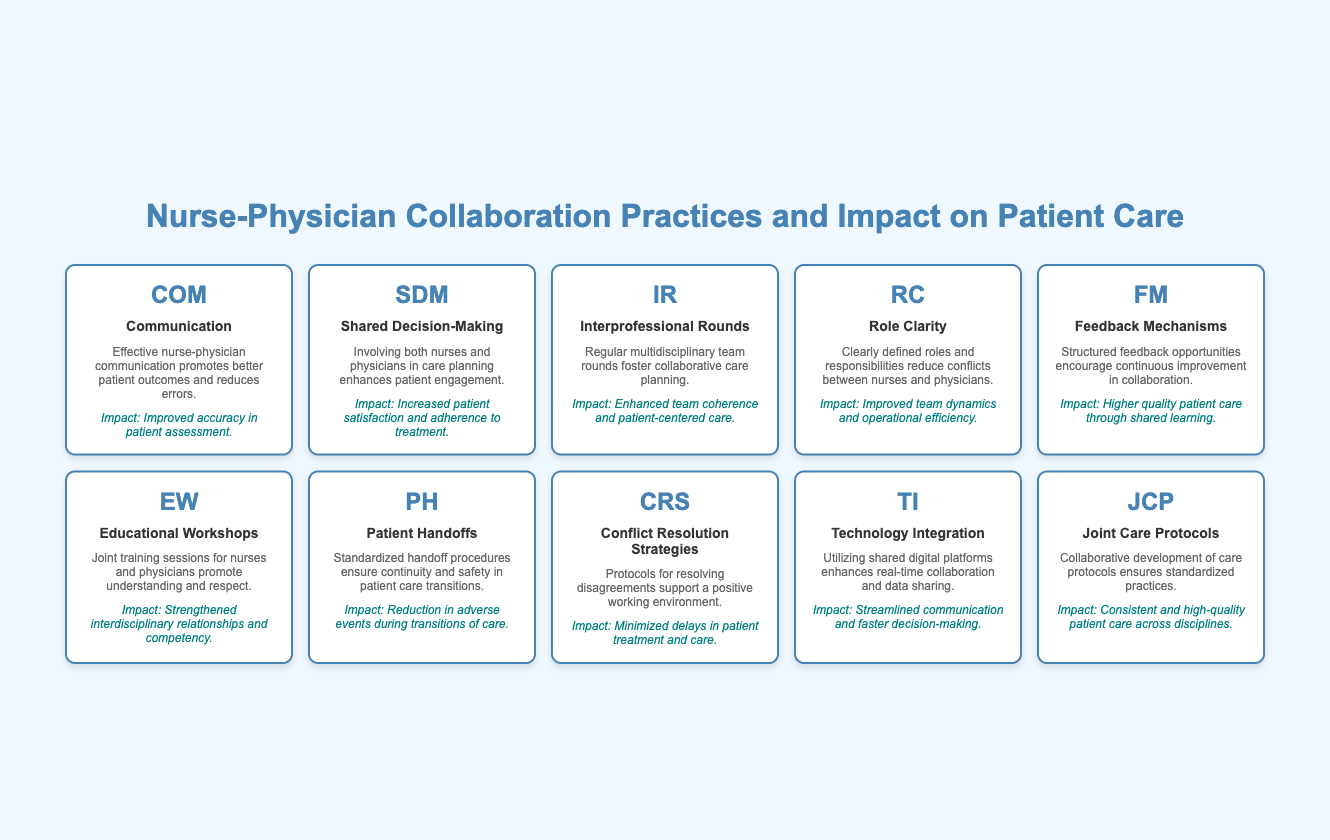What is the symbol for "Shared Decision-Making"? The table lists the symbols alongside their corresponding elements. By locating "Shared Decision-Making" in the table, I see that its symbol is "SDM".
Answer: SDM What impact does "Role Clarity" have on teamwork? The table describes the impact of each collaboration practice. "Role Clarity" leads to "Improved team dynamics and operational efficiency", indicating its positive effect on teamwork.
Answer: Improved team dynamics and operational efficiency How many collaboration practices listed have an impact related to patient satisfaction? I will review each element in the table to identify impacts linked to patient satisfaction. "Shared Decision-Making" mentions increased patient satisfaction, while "Feedback Mechanisms" indirectly relates through quality care but doesn't explicitly state satisfaction. Therefore, only one element is directly tied to patient satisfaction.
Answer: 1 Is "Technology Integration" associated with slower decision-making? The table states that "Technology Integration" results in "Streamlined communication and faster decision-making." Since it does not support slower decision-making, the answer is false.
Answer: False Which collaboration practice is directly related to patient care transitions? The only practice mentioning care transitions is "Patient Handoffs". I check the description and see it focuses on ensuring continuity and safety during transitions, making it the relevant practice.
Answer: Patient Handoffs What is the difference in impact between "Educational Workshops" and "Feedback Mechanisms"? I find the impacts listed for each. "Educational Workshops" leads to "Strengthened interdisciplinary relationships and competency", while "Feedback Mechanisms" results in "Higher quality patient care through shared learning." The difference is that one focuses on relationships, whereas the other emphasizes quality of care.
Answer: Focus on relationships and quality of care Which two elements emphasize the importance of communication? I will identify elements mentioning communication. "Communication" (directly) and "Technology Integration" (indirectly through digital platforms) both highlight communication's importance in collaboration, making them the relevant elements.
Answer: Communication and Technology Integration What is the common impact of "Interprofessional Rounds" and "Joint Care Protocols"? Starting with each element's impact, "Interprofessional Rounds" promotes "Enhanced team coherence and patient-centered care", while "Joint Care Protocols" ensures "Consistent and high-quality patient care across disciplines." The common theme is that they both positively affect patient-centered care and performance.
Answer: Positive effect on patient-centered care and performance Which collaboration practice focuses on resolving conflicts? I scan the table for a practice related to conflict resolution. "Conflict Resolution Strategies" explicitly mentions supporting a positive working environment, solidifying its focus on resolving conflicts as the answer.
Answer: Conflict Resolution Strategies 